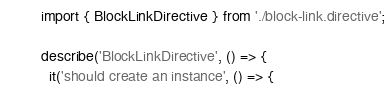Convert code to text. <code><loc_0><loc_0><loc_500><loc_500><_TypeScript_>import { BlockLinkDirective } from './block-link.directive';

describe('BlockLinkDirective', () => {
  it('should create an instance', () => {</code> 